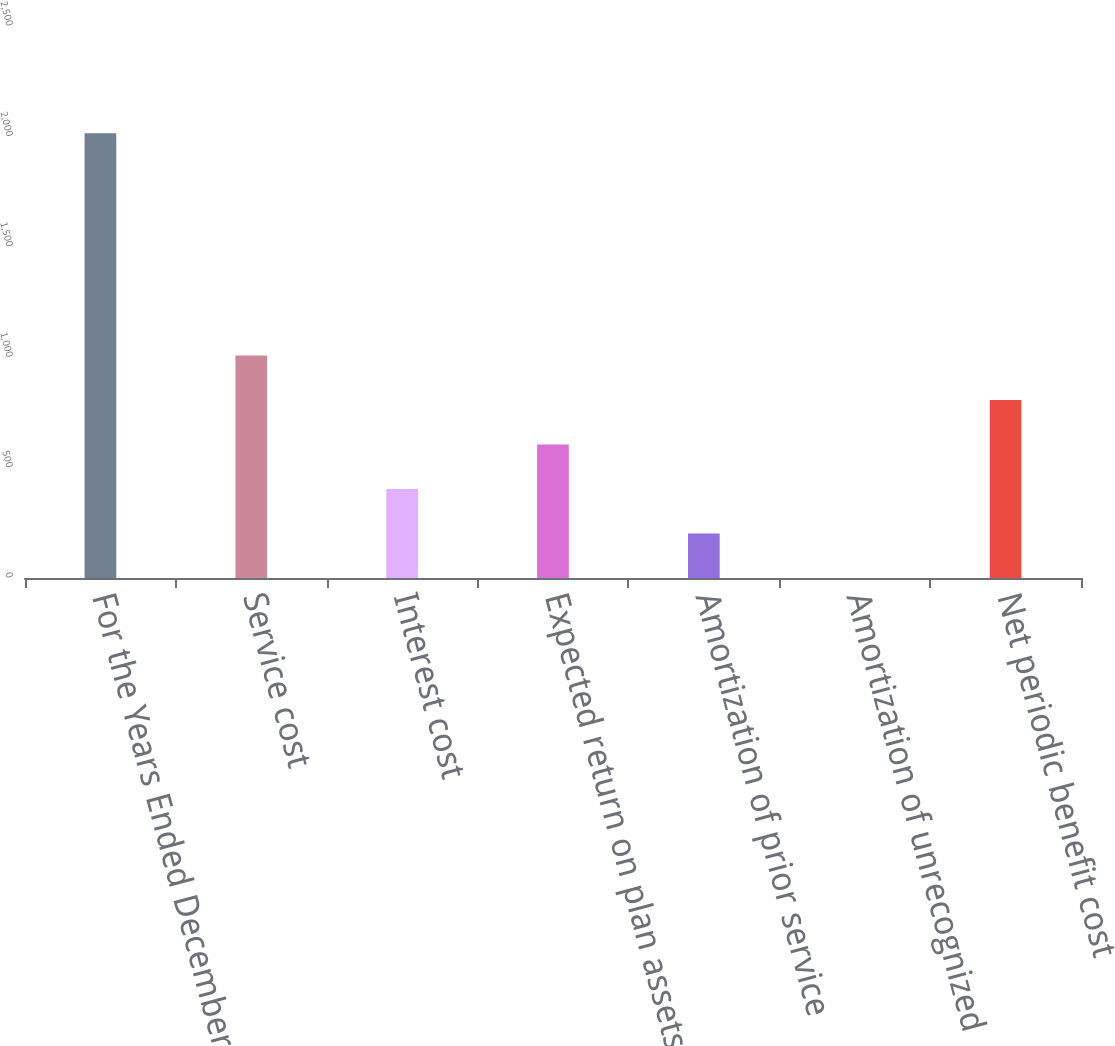Convert chart to OTSL. <chart><loc_0><loc_0><loc_500><loc_500><bar_chart><fcel>For the Years Ended December<fcel>Service cost<fcel>Interest cost<fcel>Expected return on plan assets<fcel>Amortization of prior service<fcel>Amortization of unrecognized<fcel>Net periodic benefit cost<nl><fcel>2014<fcel>1007.25<fcel>403.2<fcel>604.55<fcel>201.85<fcel>0.5<fcel>805.9<nl></chart> 